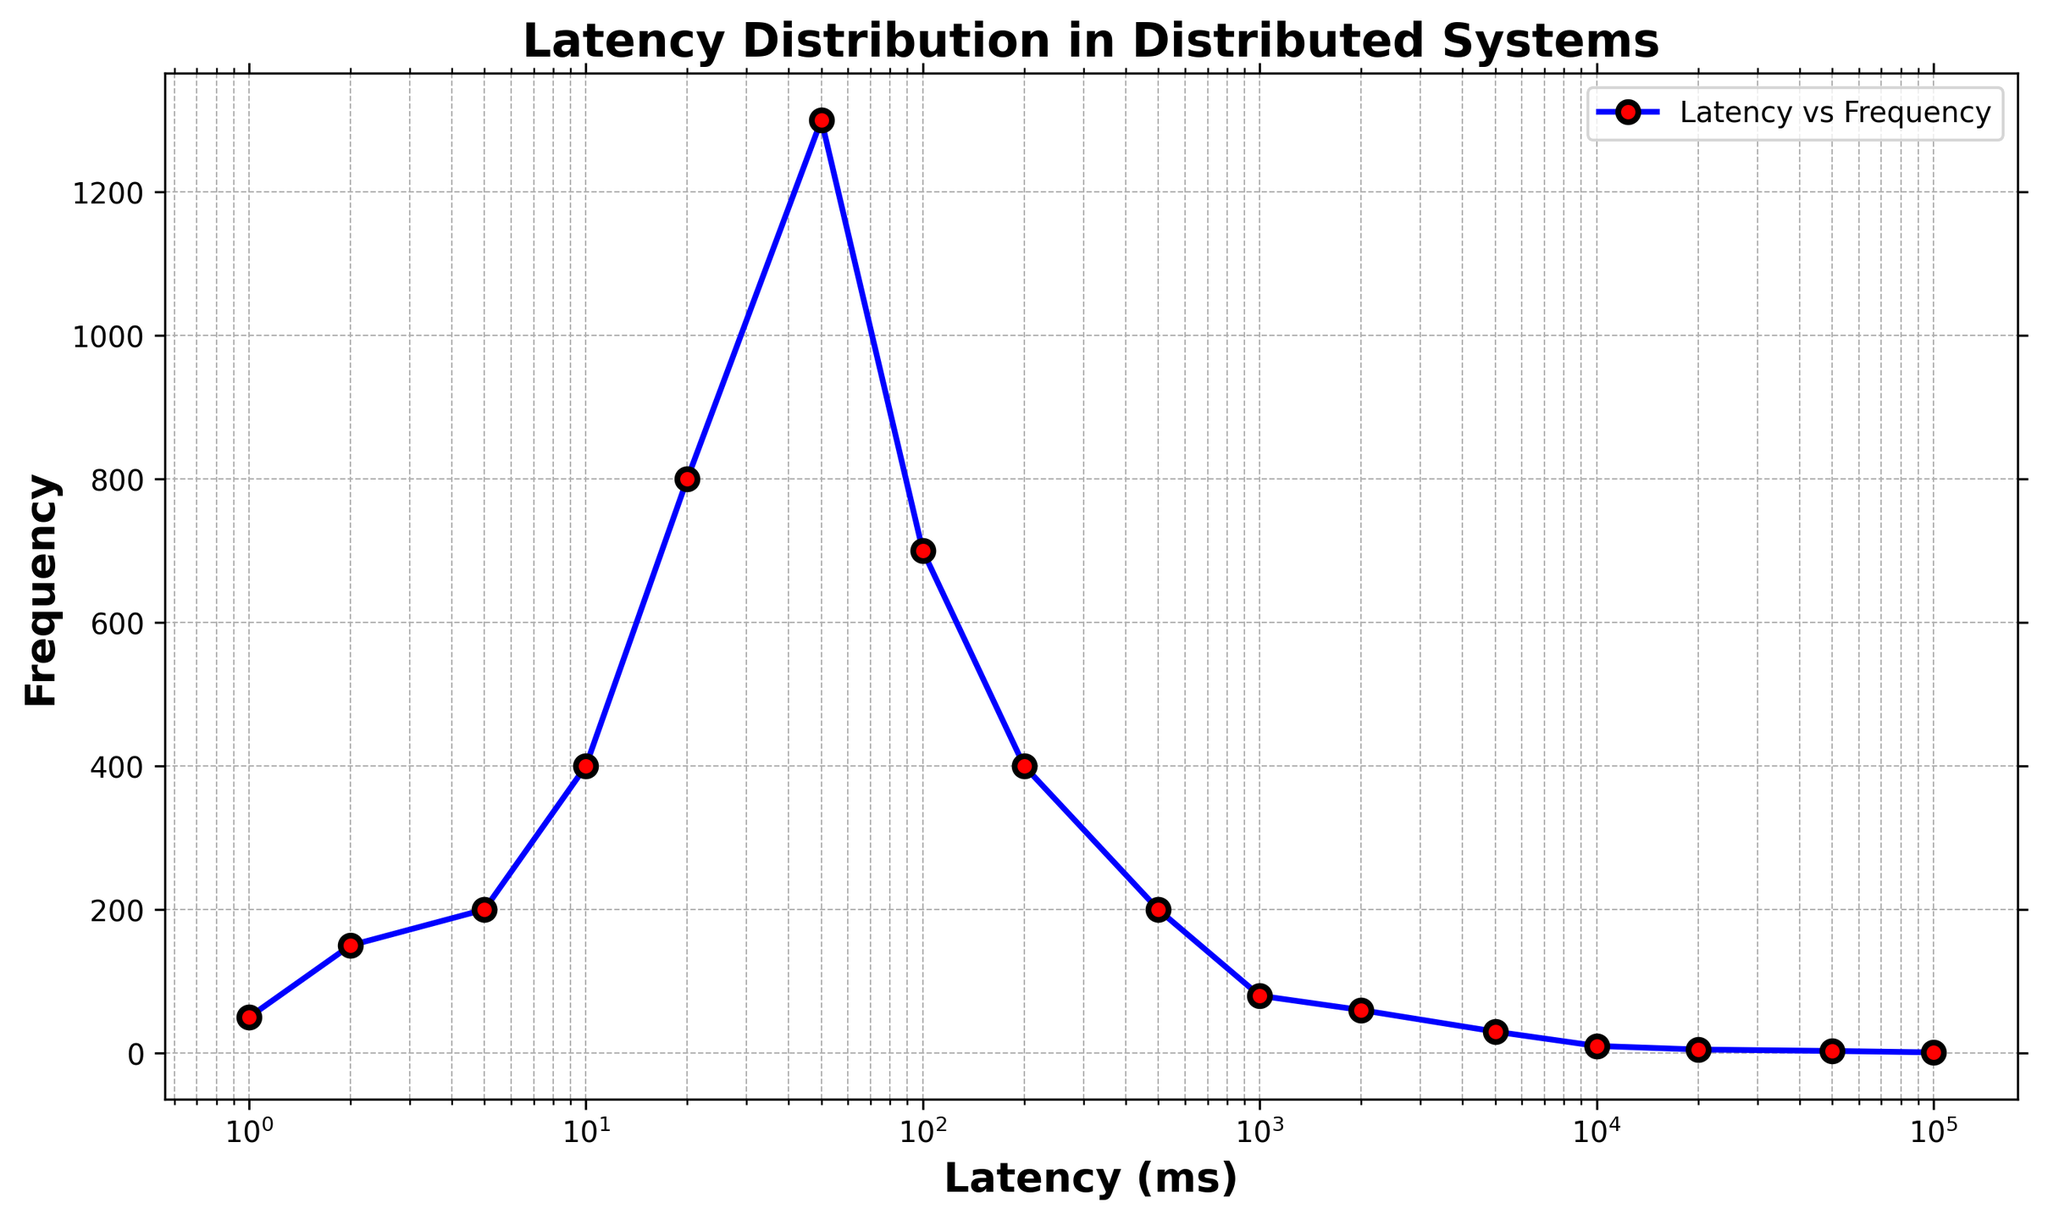How does frequency change as latency increases from 1 ms to 100 ms? Observing the plot, the frequency increases as latency moves from 1 ms to 100 ms. Specifically, it starts at 50 for 1 ms, and peaks at 1300 at 50 ms, then begins decreasing.
Answer: It increases and then starts to decrease What is the latency value at the highest frequency on the chart? The highest frequency on the chart is 1300. By referencing the plot, this highest frequency occurs at a latency of 50 ms.
Answer: 50 ms Is there a noticeable trend in the frequency for latencies above 100 ms? From the plot, for latencies above 100 ms, the frequency generally decreases as latency increases. The specific values are 700 at 100 ms, 400 at 200 ms, and so on.
Answer: Decreasing trend Which two consecutive latency points exhibit the largest increase in frequency? By examining the plot, the largest increase in frequency between consecutive latency points occurs between 20 ms and 50 ms, where the frequency jumps from 800 to 1300.
Answer: Between 20 ms and 50 ms Compare the frequency at 200 ms and 2000 ms. Which one is higher, and by how much? Referring to the plot, the frequency at 200 ms is 400 and at 2000 ms is 60. To compare, subtract 60 from 400, resulting in the frequency at 200 ms being higher by 340.
Answer: 200 ms is higher by 340 How does the visual style of the markers help in distinguishing points on the plot? The plot uses red markers with a black edge for each latency-frequency data point, which stands out against the blue line, making it easier to distinguish each point accurately.
Answer: Red markers with black edges What is the frequency difference between the latencies of 1000 ms and 50000 ms? From the plot, the frequency at 1000 ms is 80 and at 50000 ms is 3. Subtracting, the difference is 80 - 3 = 77.
Answer: 77 How many latency points have a frequency greater than 100? By counting the points on the plot, latency values with frequencies greater than 100 are at 2 ms (150), 5 ms (200), 10 ms (400), 20 ms (800), 50 ms (1300), and 100 ms (700). This gives us six points.
Answer: Six What is the relationship between frequency and latency for values above 5000 ms? Observing the plot for values above 5000 ms, the frequency continues to drop as latency increases, with the values being 30 at 5000 ms, 10 at 10000 ms, 5 at 20000 ms, 3 at 50000 ms, and 1 at 100000 ms.
Answer: Frequency decreases 